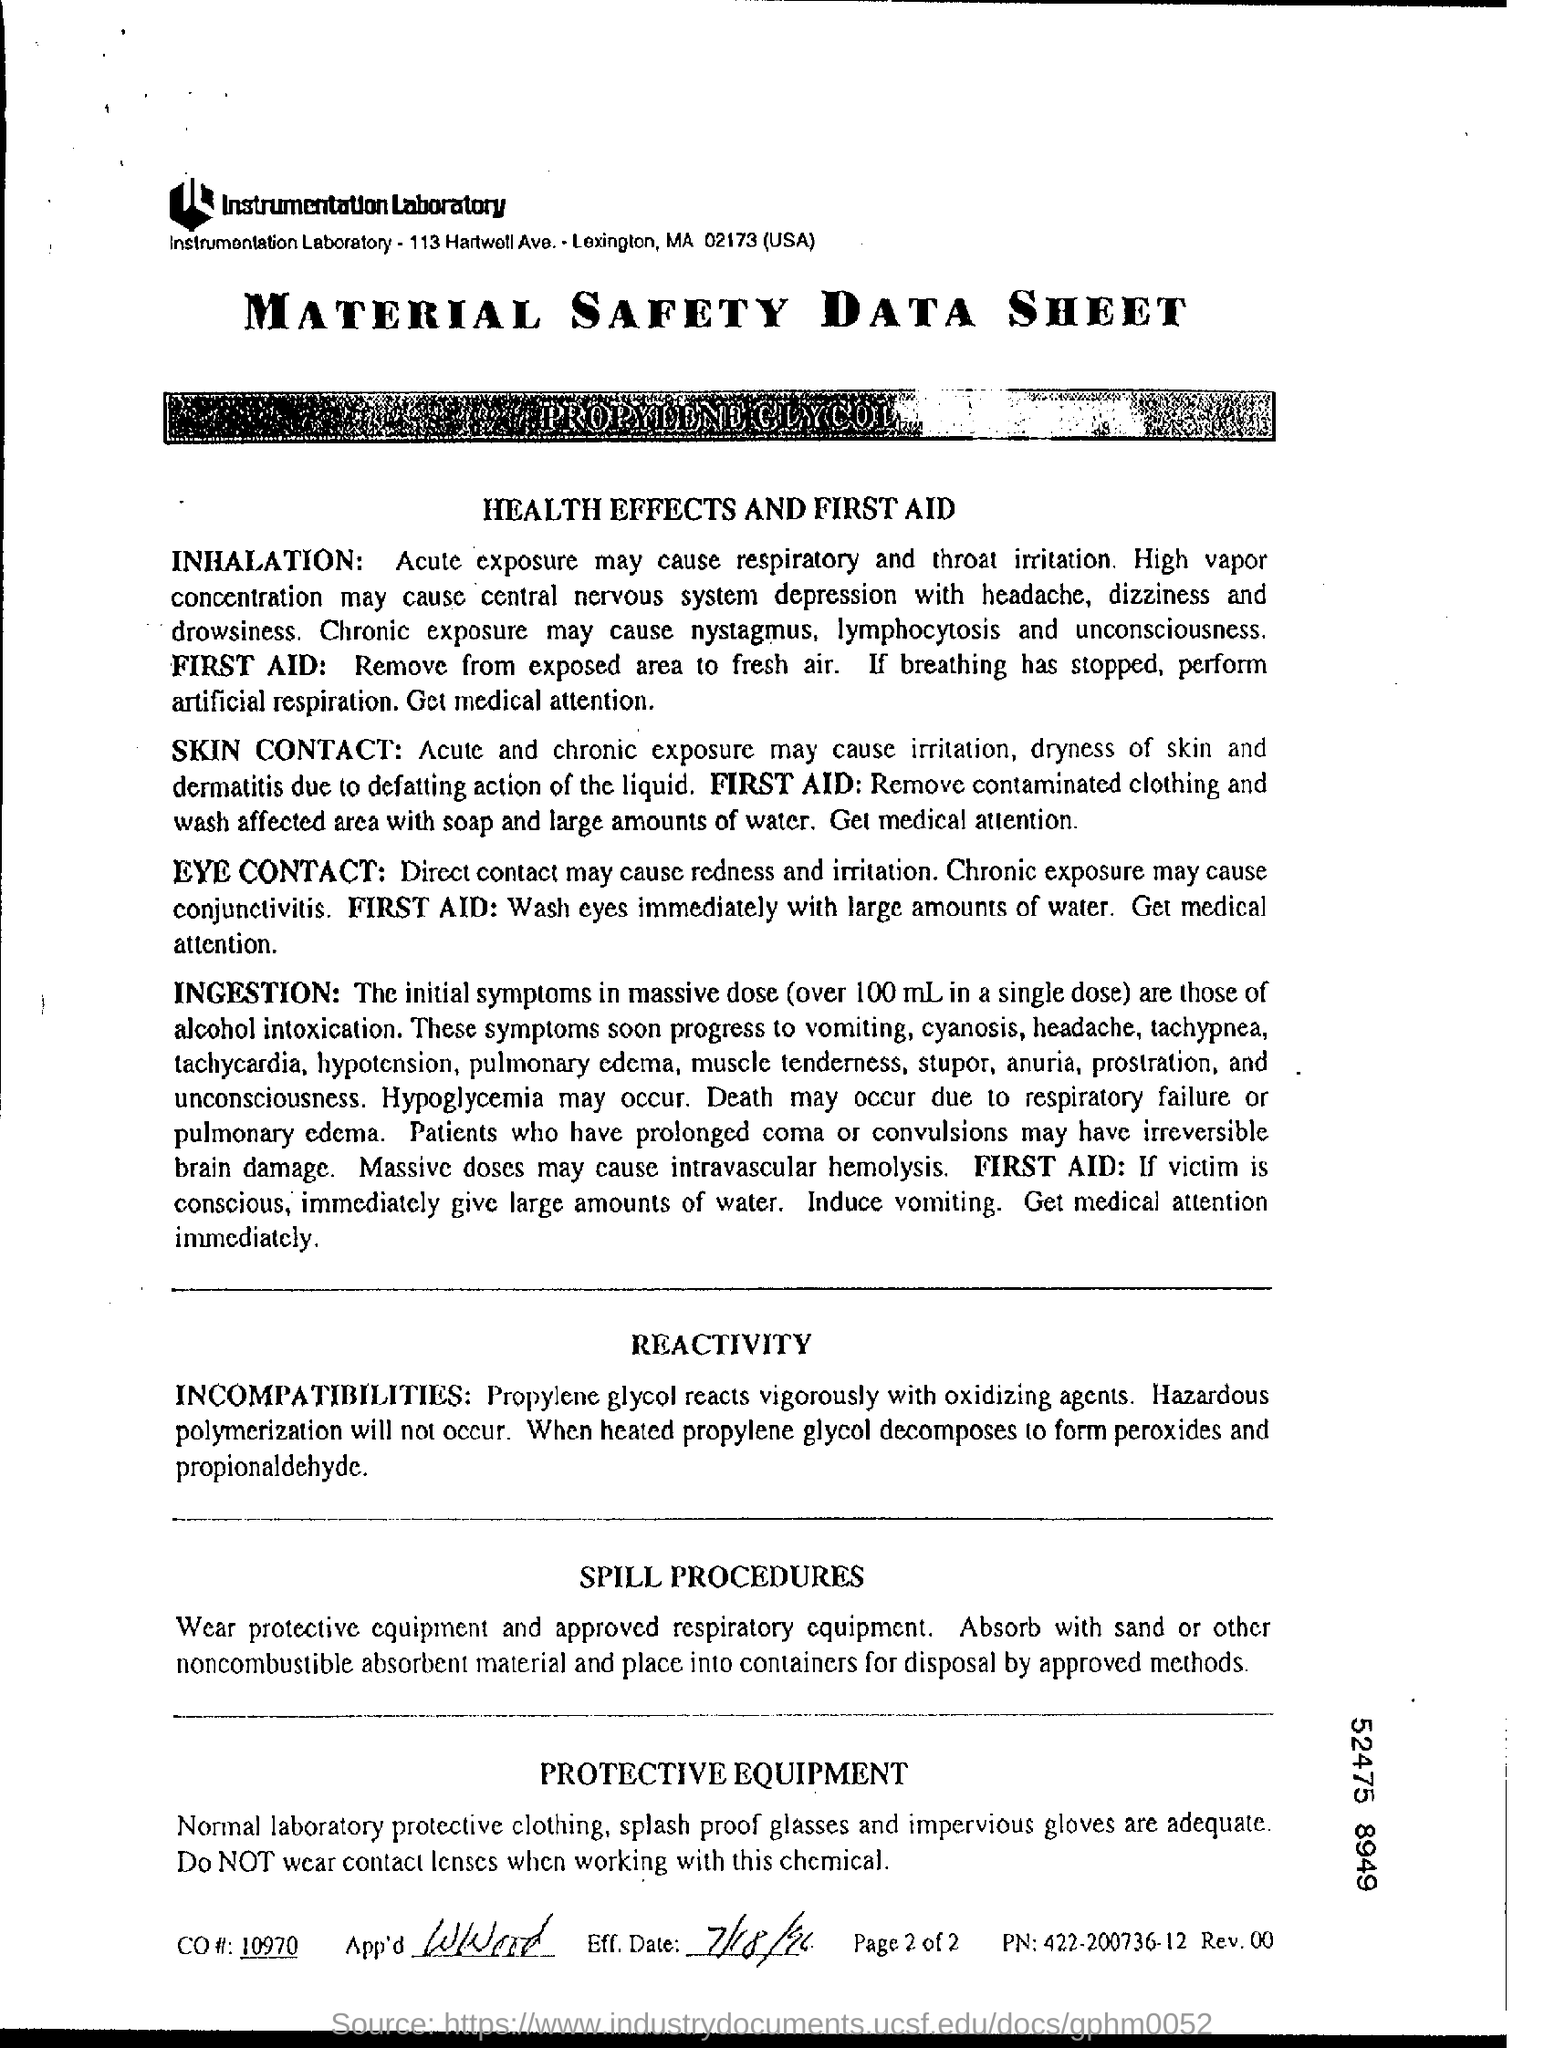Outline some significant characteristics in this image. The CO number is 10970. PN" refers to a specific identifier or code associated with an object or item. The specific identifier or code is "422-200736-12...". The effective date of July 18, 1996, is the date upon which a particular action or event takes place. The document's title is "Material Safety Data Sheet. 